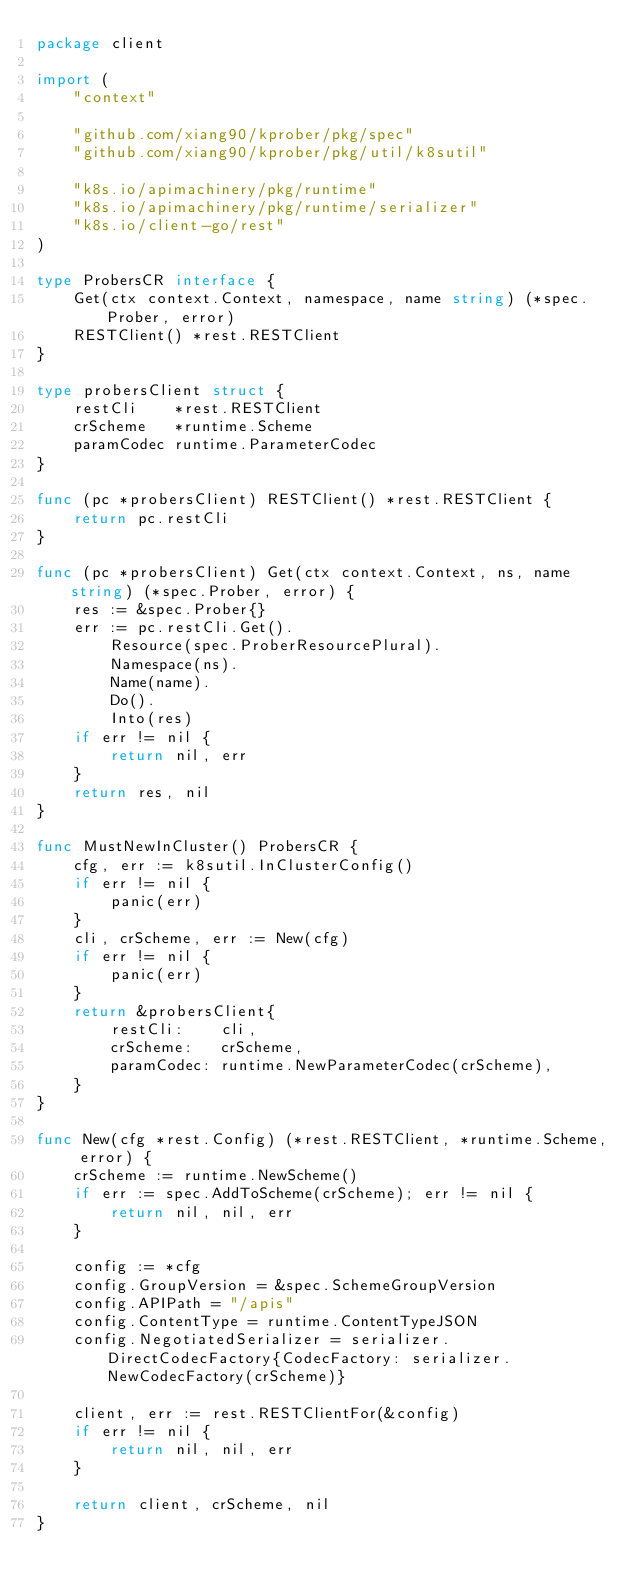<code> <loc_0><loc_0><loc_500><loc_500><_Go_>package client

import (
	"context"

	"github.com/xiang90/kprober/pkg/spec"
	"github.com/xiang90/kprober/pkg/util/k8sutil"

	"k8s.io/apimachinery/pkg/runtime"
	"k8s.io/apimachinery/pkg/runtime/serializer"
	"k8s.io/client-go/rest"
)

type ProbersCR interface {
	Get(ctx context.Context, namespace, name string) (*spec.Prober, error)
	RESTClient() *rest.RESTClient
}

type probersClient struct {
	restCli    *rest.RESTClient
	crScheme   *runtime.Scheme
	paramCodec runtime.ParameterCodec
}

func (pc *probersClient) RESTClient() *rest.RESTClient {
	return pc.restCli
}

func (pc *probersClient) Get(ctx context.Context, ns, name string) (*spec.Prober, error) {
	res := &spec.Prober{}
	err := pc.restCli.Get().
		Resource(spec.ProberResourcePlural).
		Namespace(ns).
		Name(name).
		Do().
		Into(res)
	if err != nil {
		return nil, err
	}
	return res, nil
}

func MustNewInCluster() ProbersCR {
	cfg, err := k8sutil.InClusterConfig()
	if err != nil {
		panic(err)
	}
	cli, crScheme, err := New(cfg)
	if err != nil {
		panic(err)
	}
	return &probersClient{
		restCli:    cli,
		crScheme:   crScheme,
		paramCodec: runtime.NewParameterCodec(crScheme),
	}
}

func New(cfg *rest.Config) (*rest.RESTClient, *runtime.Scheme, error) {
	crScheme := runtime.NewScheme()
	if err := spec.AddToScheme(crScheme); err != nil {
		return nil, nil, err
	}

	config := *cfg
	config.GroupVersion = &spec.SchemeGroupVersion
	config.APIPath = "/apis"
	config.ContentType = runtime.ContentTypeJSON
	config.NegotiatedSerializer = serializer.DirectCodecFactory{CodecFactory: serializer.NewCodecFactory(crScheme)}

	client, err := rest.RESTClientFor(&config)
	if err != nil {
		return nil, nil, err
	}

	return client, crScheme, nil
}
</code> 